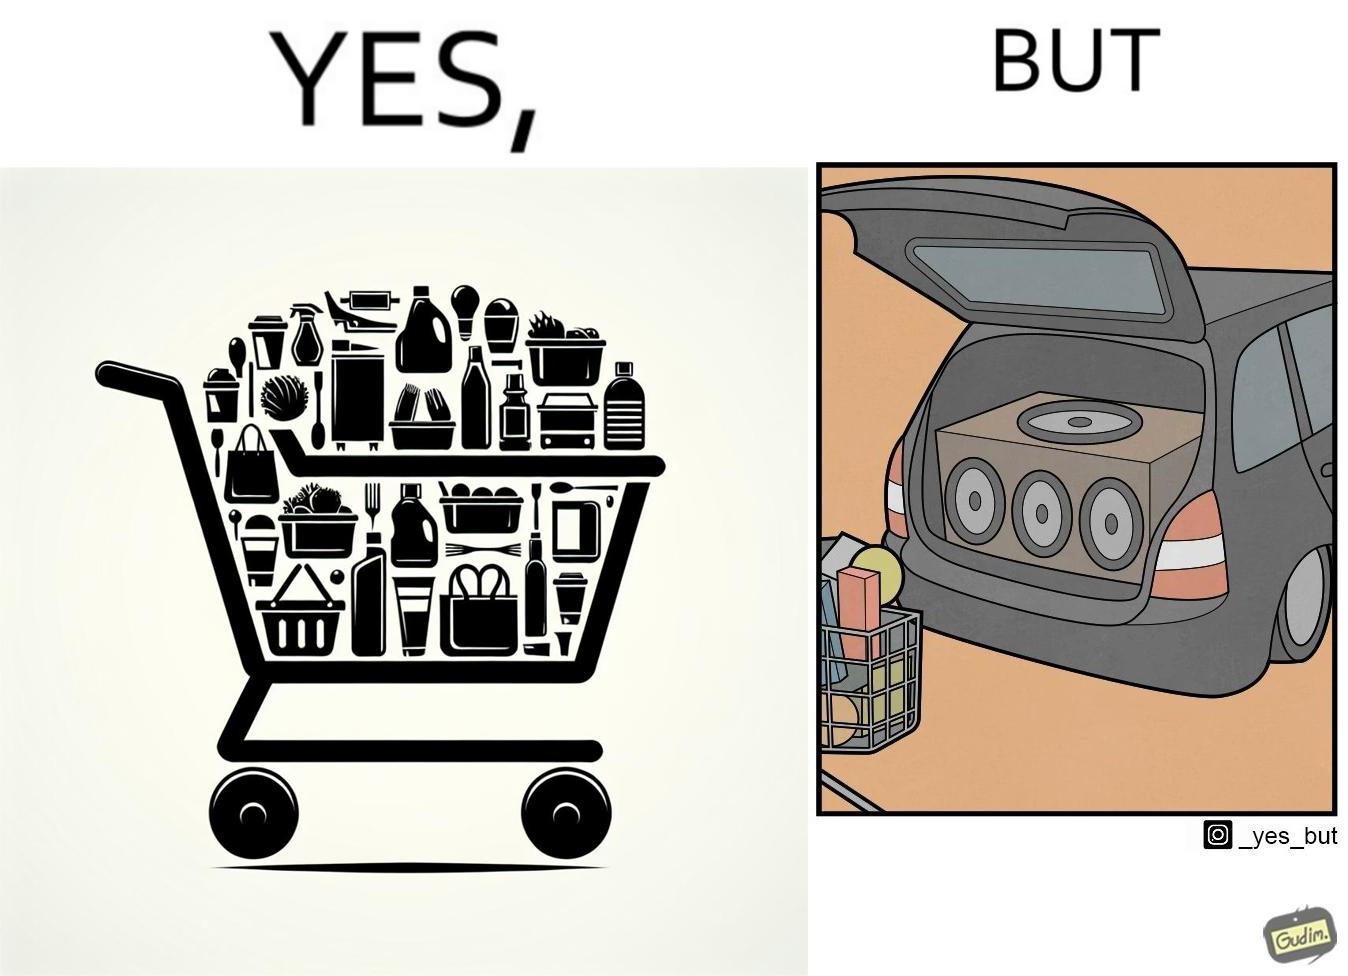What do you see in each half of this image? In the left part of the image: a shopping cart full of items In the right part of the image: a black car with its trunk lid open and some boxes, probably speakers, kept in the trunk 